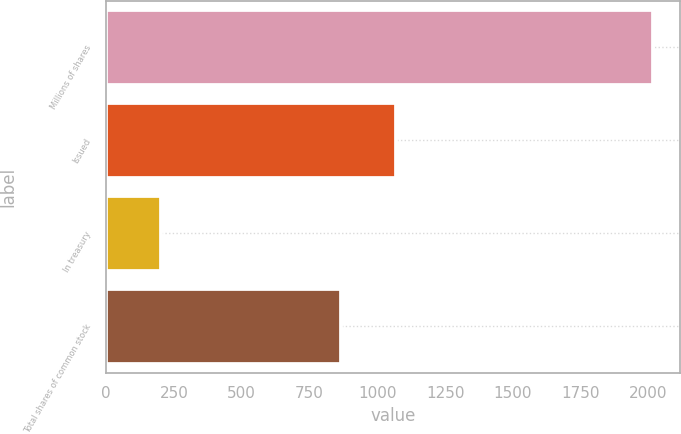Convert chart to OTSL. <chart><loc_0><loc_0><loc_500><loc_500><bar_chart><fcel>Millions of shares<fcel>Issued<fcel>In treasury<fcel>Total shares of common stock<nl><fcel>2016<fcel>1070<fcel>204<fcel>866<nl></chart> 